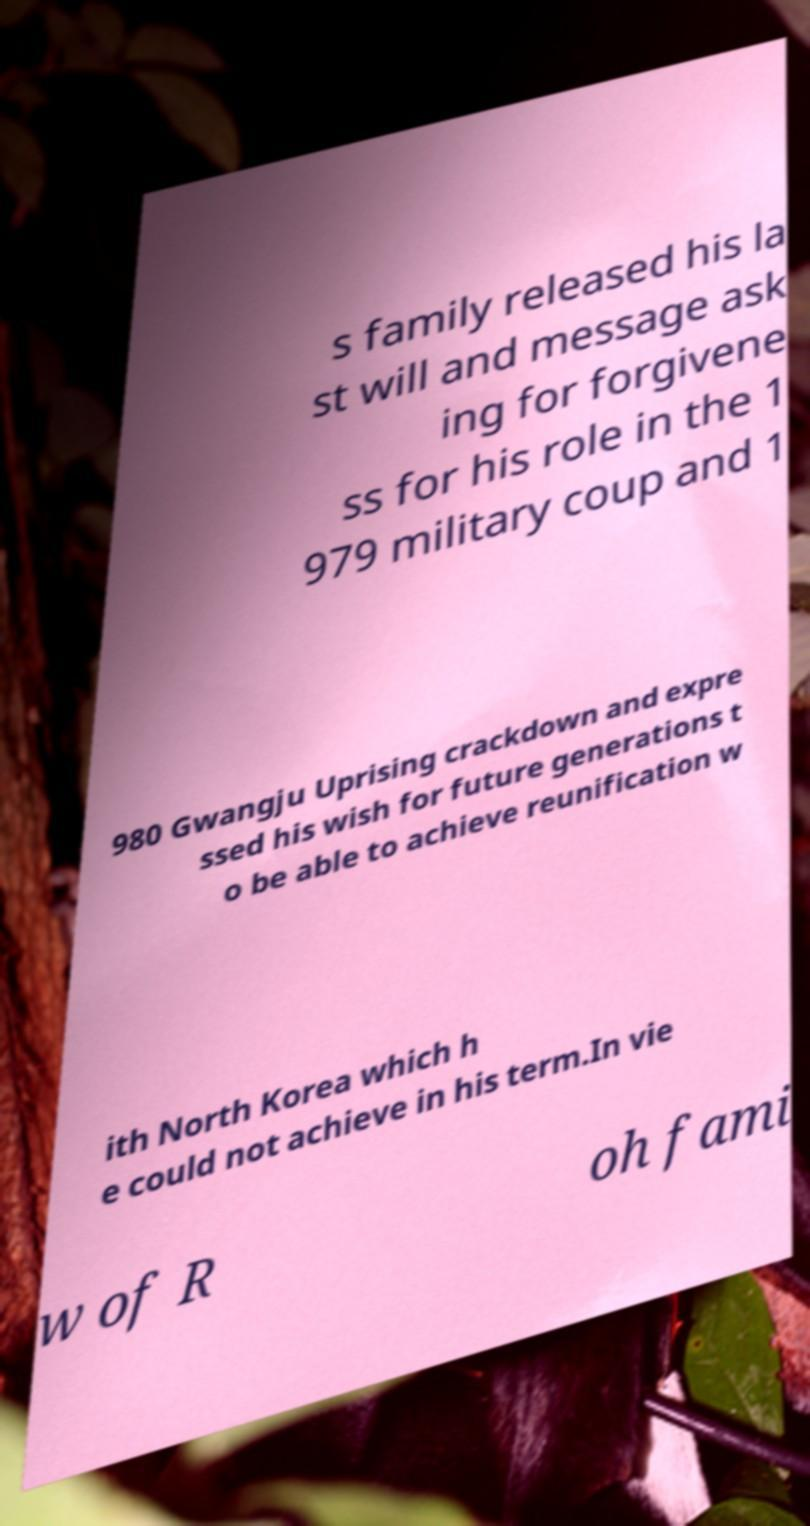Can you read and provide the text displayed in the image?This photo seems to have some interesting text. Can you extract and type it out for me? s family released his la st will and message ask ing for forgivene ss for his role in the 1 979 military coup and 1 980 Gwangju Uprising crackdown and expre ssed his wish for future generations t o be able to achieve reunification w ith North Korea which h e could not achieve in his term.In vie w of R oh fami 